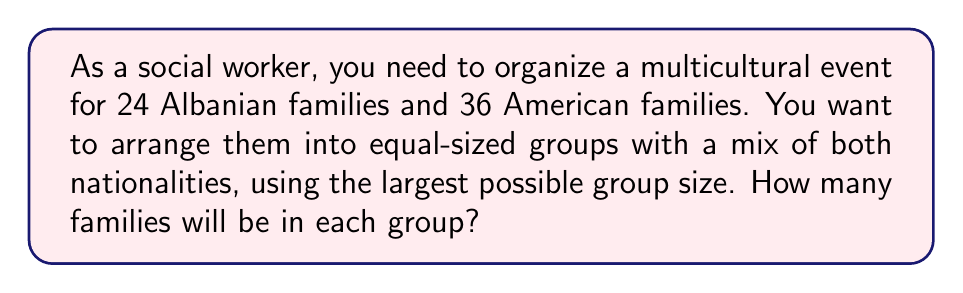Could you help me with this problem? To solve this problem, we need to find the Least Common Multiple (LCM) of 24 and 36.

Step 1: Factor the numbers
$24 = 2^3 \times 3$
$36 = 2^2 \times 3^2$

Step 2: Identify the highest power of each prime factor
$2^3 = 8$ (from 24)
$3^2 = 9$ (from 36)

Step 3: Multiply the highest powers
$LCM(24, 36) = 2^3 \times 3^2 = 8 \times 9 = 72$

The LCM of 24 and 36 is 72, which means we can arrange the families into groups of 72.

Step 4: Calculate the number of families in each group
Albanian families in each group: $72 \div 24 = 3$
American families in each group: $72 \div 36 = 2$

Therefore, each group will consist of 3 + 2 = 5 families.
Answer: 5 families 